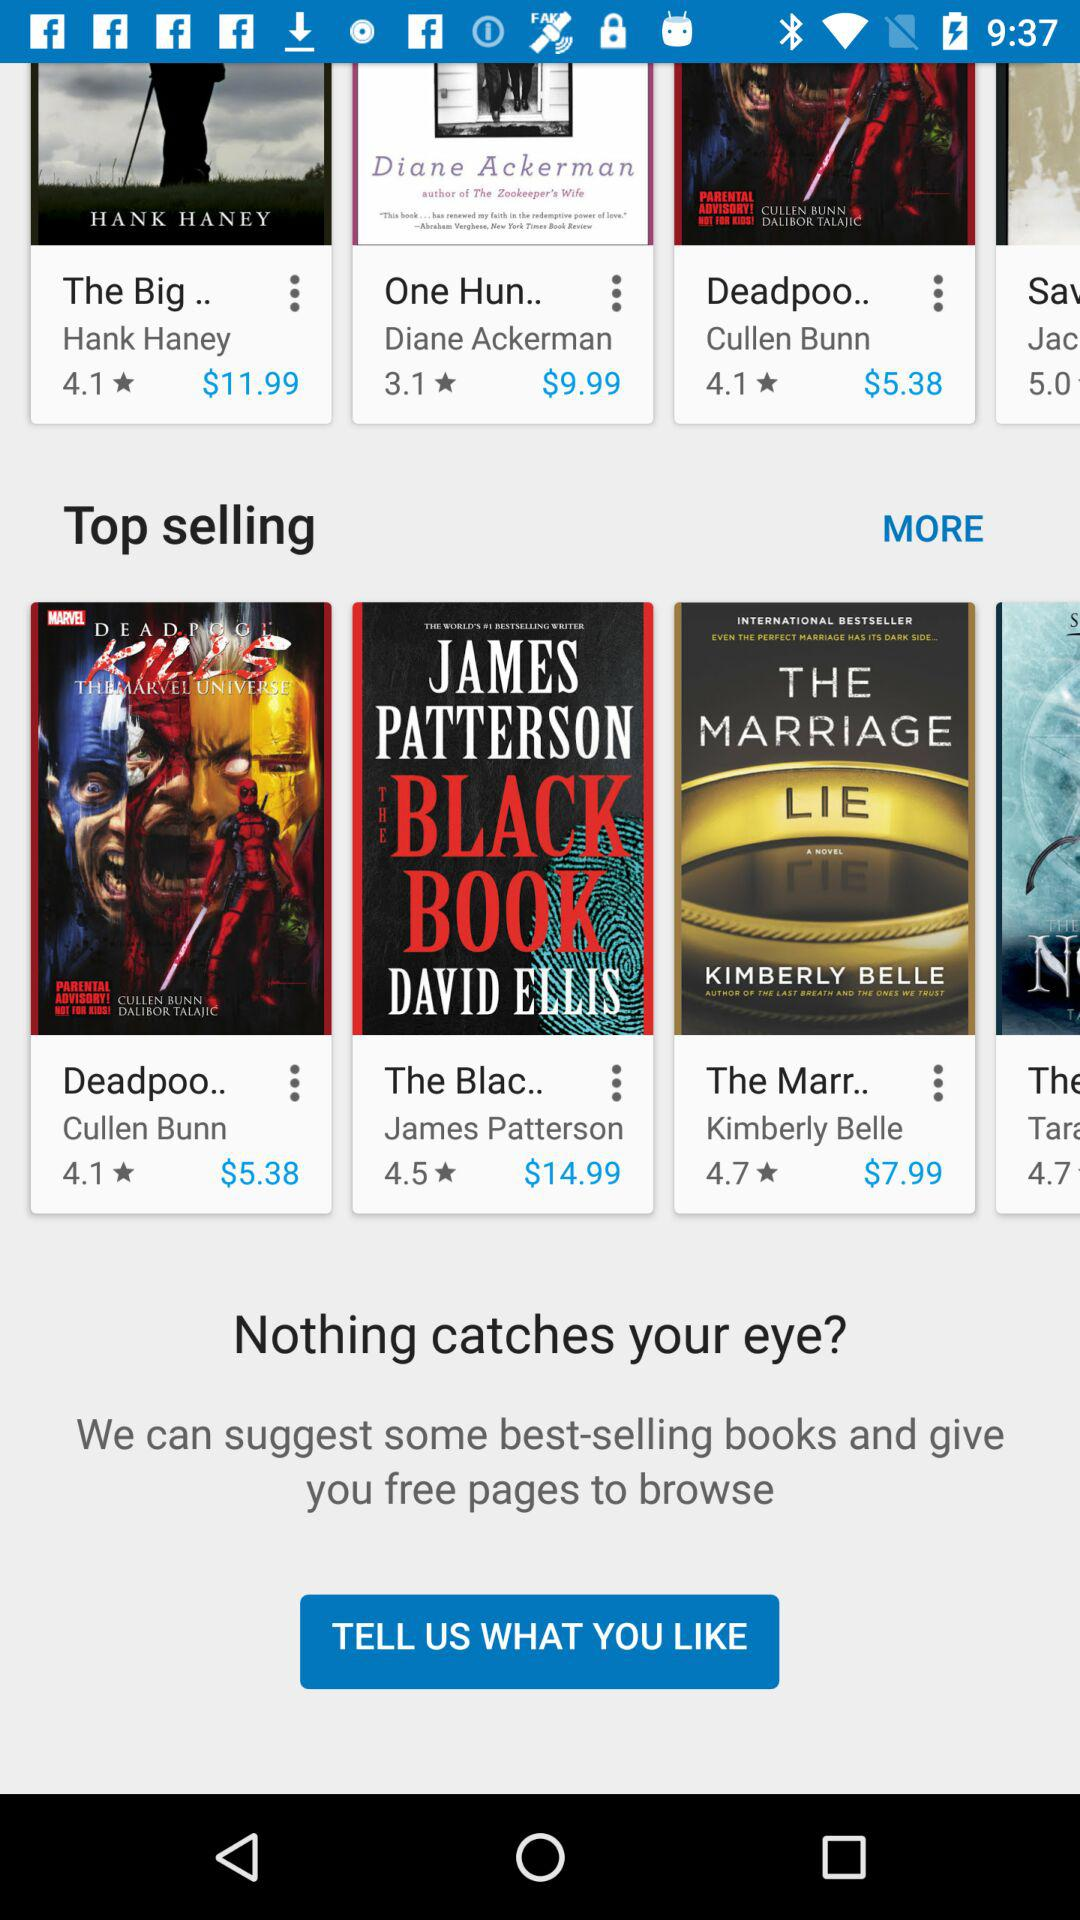What is the price of the book "Deadpool"? The price is $5.38. 